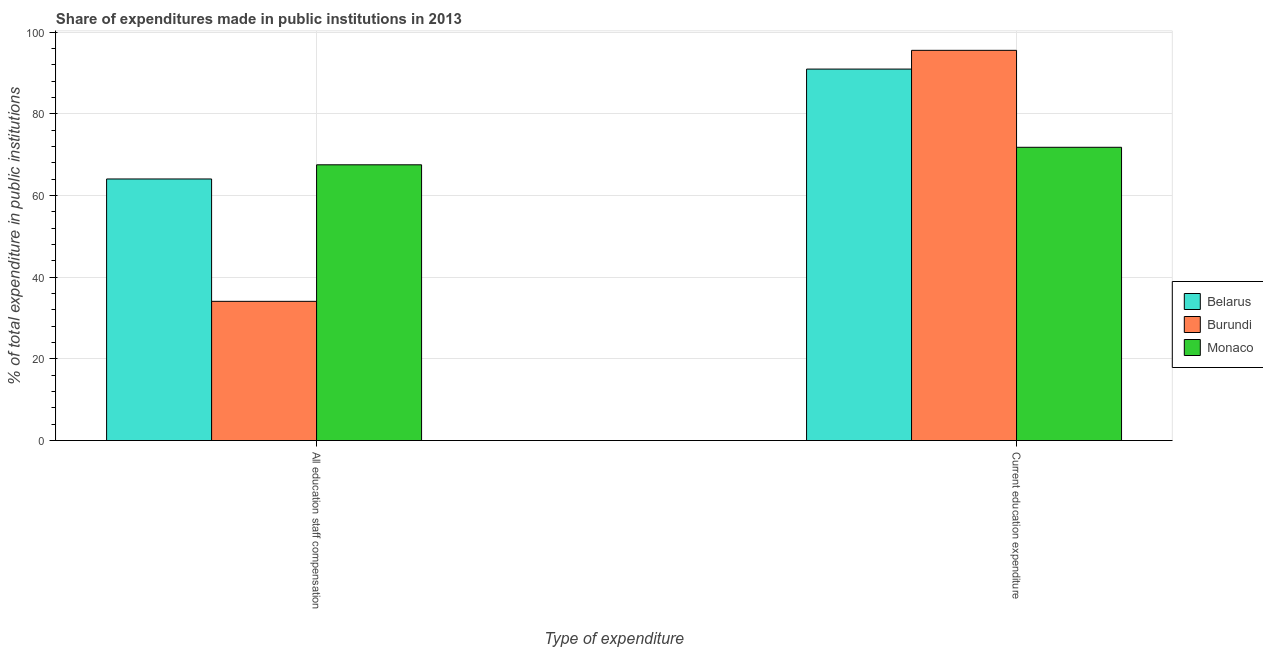Are the number of bars on each tick of the X-axis equal?
Give a very brief answer. Yes. How many bars are there on the 2nd tick from the left?
Your answer should be very brief. 3. What is the label of the 2nd group of bars from the left?
Keep it short and to the point. Current education expenditure. What is the expenditure in education in Belarus?
Your answer should be very brief. 90.94. Across all countries, what is the maximum expenditure in education?
Provide a succinct answer. 95.53. Across all countries, what is the minimum expenditure in staff compensation?
Give a very brief answer. 34.08. In which country was the expenditure in education maximum?
Ensure brevity in your answer.  Burundi. In which country was the expenditure in education minimum?
Make the answer very short. Monaco. What is the total expenditure in staff compensation in the graph?
Provide a short and direct response. 165.64. What is the difference between the expenditure in staff compensation in Burundi and that in Belarus?
Your answer should be compact. -29.96. What is the difference between the expenditure in education in Monaco and the expenditure in staff compensation in Belarus?
Provide a succinct answer. 7.76. What is the average expenditure in staff compensation per country?
Provide a succinct answer. 55.21. What is the difference between the expenditure in staff compensation and expenditure in education in Monaco?
Your answer should be very brief. -4.29. What is the ratio of the expenditure in education in Belarus to that in Burundi?
Give a very brief answer. 0.95. Is the expenditure in education in Burundi less than that in Belarus?
Your response must be concise. No. In how many countries, is the expenditure in education greater than the average expenditure in education taken over all countries?
Provide a succinct answer. 2. What does the 3rd bar from the left in All education staff compensation represents?
Provide a succinct answer. Monaco. What does the 3rd bar from the right in Current education expenditure represents?
Your answer should be compact. Belarus. How many bars are there?
Keep it short and to the point. 6. How many countries are there in the graph?
Provide a short and direct response. 3. Does the graph contain any zero values?
Give a very brief answer. No. Does the graph contain grids?
Give a very brief answer. Yes. Where does the legend appear in the graph?
Keep it short and to the point. Center right. How many legend labels are there?
Offer a very short reply. 3. How are the legend labels stacked?
Ensure brevity in your answer.  Vertical. What is the title of the graph?
Your response must be concise. Share of expenditures made in public institutions in 2013. What is the label or title of the X-axis?
Provide a short and direct response. Type of expenditure. What is the label or title of the Y-axis?
Offer a very short reply. % of total expenditure in public institutions. What is the % of total expenditure in public institutions of Belarus in All education staff compensation?
Keep it short and to the point. 64.04. What is the % of total expenditure in public institutions in Burundi in All education staff compensation?
Make the answer very short. 34.08. What is the % of total expenditure in public institutions of Monaco in All education staff compensation?
Make the answer very short. 67.51. What is the % of total expenditure in public institutions of Belarus in Current education expenditure?
Provide a short and direct response. 90.94. What is the % of total expenditure in public institutions in Burundi in Current education expenditure?
Provide a short and direct response. 95.53. What is the % of total expenditure in public institutions in Monaco in Current education expenditure?
Provide a succinct answer. 71.8. Across all Type of expenditure, what is the maximum % of total expenditure in public institutions of Belarus?
Make the answer very short. 90.94. Across all Type of expenditure, what is the maximum % of total expenditure in public institutions in Burundi?
Make the answer very short. 95.53. Across all Type of expenditure, what is the maximum % of total expenditure in public institutions in Monaco?
Offer a very short reply. 71.8. Across all Type of expenditure, what is the minimum % of total expenditure in public institutions of Belarus?
Keep it short and to the point. 64.04. Across all Type of expenditure, what is the minimum % of total expenditure in public institutions of Burundi?
Offer a terse response. 34.08. Across all Type of expenditure, what is the minimum % of total expenditure in public institutions of Monaco?
Provide a succinct answer. 67.51. What is the total % of total expenditure in public institutions of Belarus in the graph?
Provide a succinct answer. 154.98. What is the total % of total expenditure in public institutions of Burundi in the graph?
Keep it short and to the point. 129.62. What is the total % of total expenditure in public institutions of Monaco in the graph?
Your answer should be compact. 139.31. What is the difference between the % of total expenditure in public institutions of Belarus in All education staff compensation and that in Current education expenditure?
Provide a short and direct response. -26.9. What is the difference between the % of total expenditure in public institutions of Burundi in All education staff compensation and that in Current education expenditure?
Your answer should be compact. -61.45. What is the difference between the % of total expenditure in public institutions of Monaco in All education staff compensation and that in Current education expenditure?
Make the answer very short. -4.29. What is the difference between the % of total expenditure in public institutions in Belarus in All education staff compensation and the % of total expenditure in public institutions in Burundi in Current education expenditure?
Provide a succinct answer. -31.49. What is the difference between the % of total expenditure in public institutions of Belarus in All education staff compensation and the % of total expenditure in public institutions of Monaco in Current education expenditure?
Offer a terse response. -7.76. What is the difference between the % of total expenditure in public institutions in Burundi in All education staff compensation and the % of total expenditure in public institutions in Monaco in Current education expenditure?
Offer a very short reply. -37.71. What is the average % of total expenditure in public institutions of Belarus per Type of expenditure?
Your answer should be compact. 77.49. What is the average % of total expenditure in public institutions of Burundi per Type of expenditure?
Give a very brief answer. 64.81. What is the average % of total expenditure in public institutions in Monaco per Type of expenditure?
Your response must be concise. 69.65. What is the difference between the % of total expenditure in public institutions in Belarus and % of total expenditure in public institutions in Burundi in All education staff compensation?
Keep it short and to the point. 29.96. What is the difference between the % of total expenditure in public institutions in Belarus and % of total expenditure in public institutions in Monaco in All education staff compensation?
Give a very brief answer. -3.47. What is the difference between the % of total expenditure in public institutions in Burundi and % of total expenditure in public institutions in Monaco in All education staff compensation?
Your answer should be compact. -33.42. What is the difference between the % of total expenditure in public institutions in Belarus and % of total expenditure in public institutions in Burundi in Current education expenditure?
Your answer should be compact. -4.59. What is the difference between the % of total expenditure in public institutions in Belarus and % of total expenditure in public institutions in Monaco in Current education expenditure?
Your response must be concise. 19.14. What is the difference between the % of total expenditure in public institutions in Burundi and % of total expenditure in public institutions in Monaco in Current education expenditure?
Offer a terse response. 23.73. What is the ratio of the % of total expenditure in public institutions in Belarus in All education staff compensation to that in Current education expenditure?
Give a very brief answer. 0.7. What is the ratio of the % of total expenditure in public institutions of Burundi in All education staff compensation to that in Current education expenditure?
Keep it short and to the point. 0.36. What is the ratio of the % of total expenditure in public institutions in Monaco in All education staff compensation to that in Current education expenditure?
Provide a short and direct response. 0.94. What is the difference between the highest and the second highest % of total expenditure in public institutions of Belarus?
Provide a succinct answer. 26.9. What is the difference between the highest and the second highest % of total expenditure in public institutions of Burundi?
Make the answer very short. 61.45. What is the difference between the highest and the second highest % of total expenditure in public institutions of Monaco?
Give a very brief answer. 4.29. What is the difference between the highest and the lowest % of total expenditure in public institutions of Belarus?
Give a very brief answer. 26.9. What is the difference between the highest and the lowest % of total expenditure in public institutions in Burundi?
Offer a terse response. 61.45. What is the difference between the highest and the lowest % of total expenditure in public institutions in Monaco?
Ensure brevity in your answer.  4.29. 